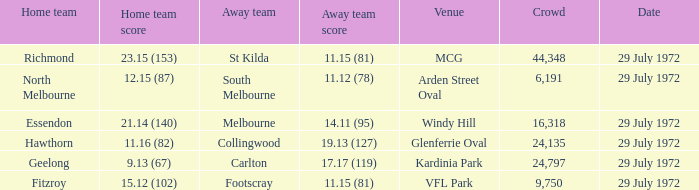What was the largest crowd size at arden street oval? 6191.0. 